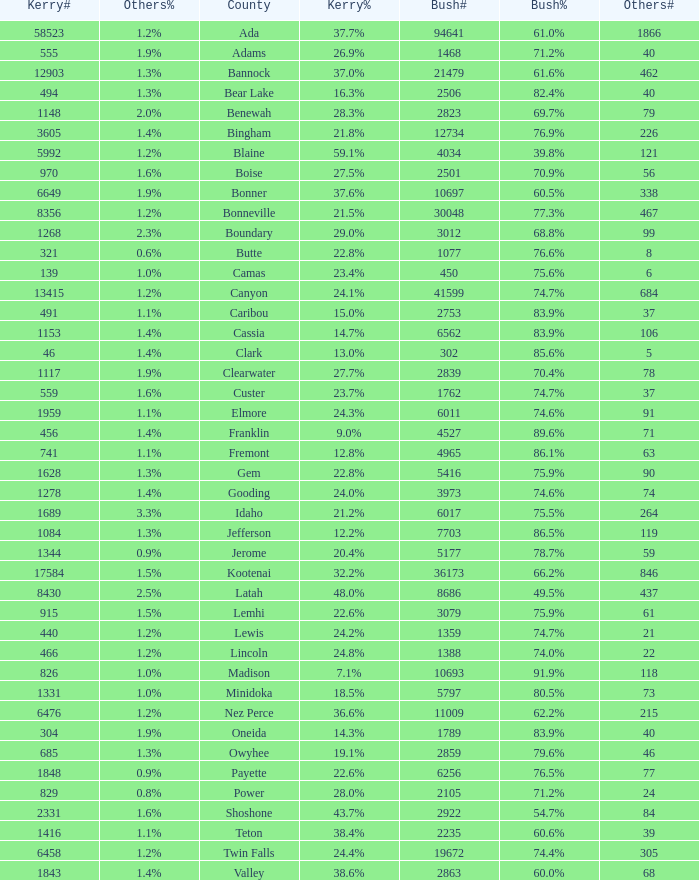What's percentage voted for Busg in the county where Kerry got 37.6%? 60.5%. 